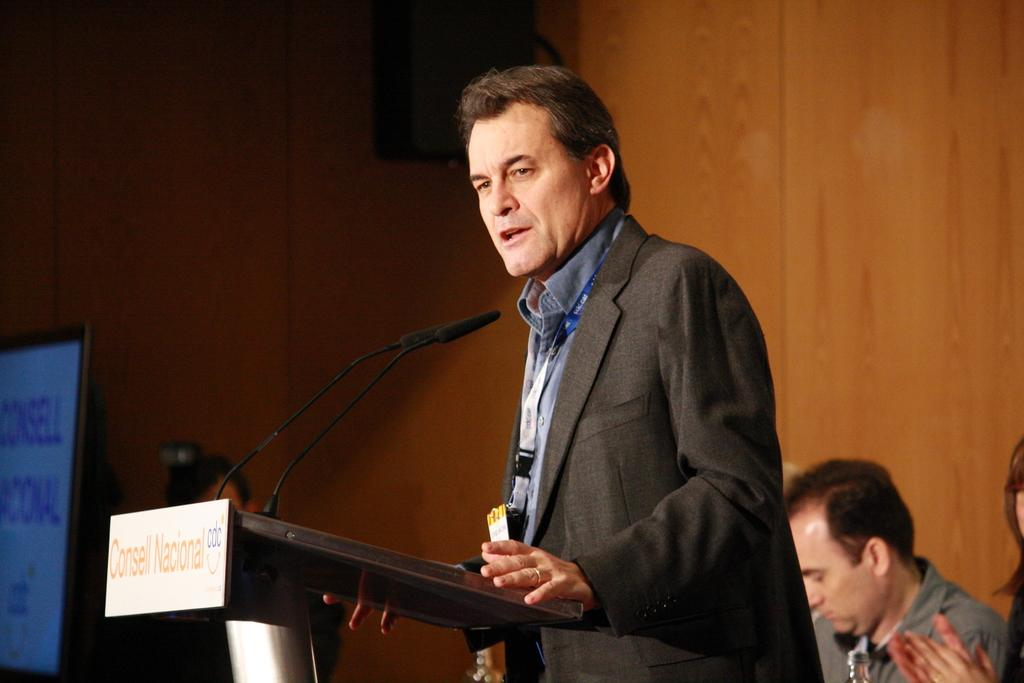What is the main subject of the image? There is a man in the image. What is the man wearing? The man is wearing a black coat. What is the man doing in the image? The man is standing and giving a speech. What can be seen in the background of the image? There is a wooden panel wall and a TV screen in the background. How many brothers does the man have, and are they present in the image? There is no information about the man's brothers in the image, so we cannot determine how many he has or if they are present. What type of footwear is the man wearing in the image? The provided facts do not mention the man's footwear, so we cannot determine what type he is wearing. 